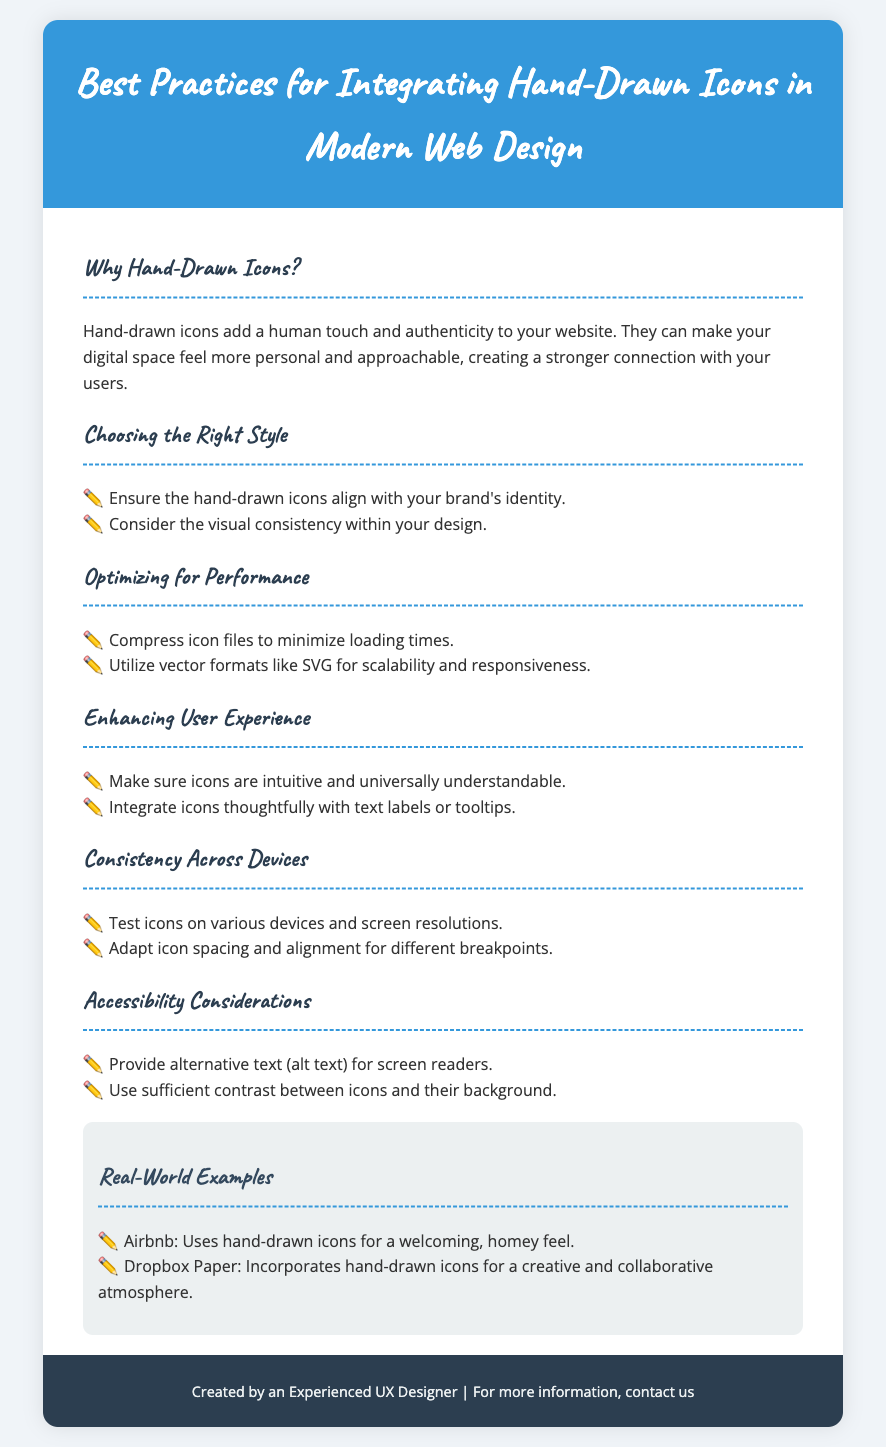What are hand-drawn icons meant to add to a website? The section "Why Hand-Drawn Icons?" states that they add a human touch and authenticity to your website.
Answer: Human touch and authenticity What format is recommended for scalability and responsiveness? The section "Optimizing for Performance" suggests utilizing vector formats like SVG.
Answer: SVG Name one example of a company that uses hand-drawn icons. The "Real-World Examples" section mentions Airbnb and Dropbox Paper.
Answer: Airbnb What should be included for screen readers? The section "Accessibility Considerations" states that you should provide alternative text (alt text).
Answer: Alternative text (alt text) Which type of contrast is important for icons? The "Accessibility Considerations" section emphasizes the use of sufficient contrast between icons and their background.
Answer: Sufficient contrast How many points are listed under "Enhancing User Experience"? The section "Enhancing User Experience" outlines two points.
Answer: Two What does the footer mention about the creator of the flyer? The footer states that it was created by an experienced UX designer.
Answer: An experienced UX designer What is the purpose of testing icons on various devices? The section "Consistency Across Devices" includes testing icons to ensure adaptation for different breakpoints, which implies verifying functionality across devices.
Answer: Adaptation for different breakpoints 